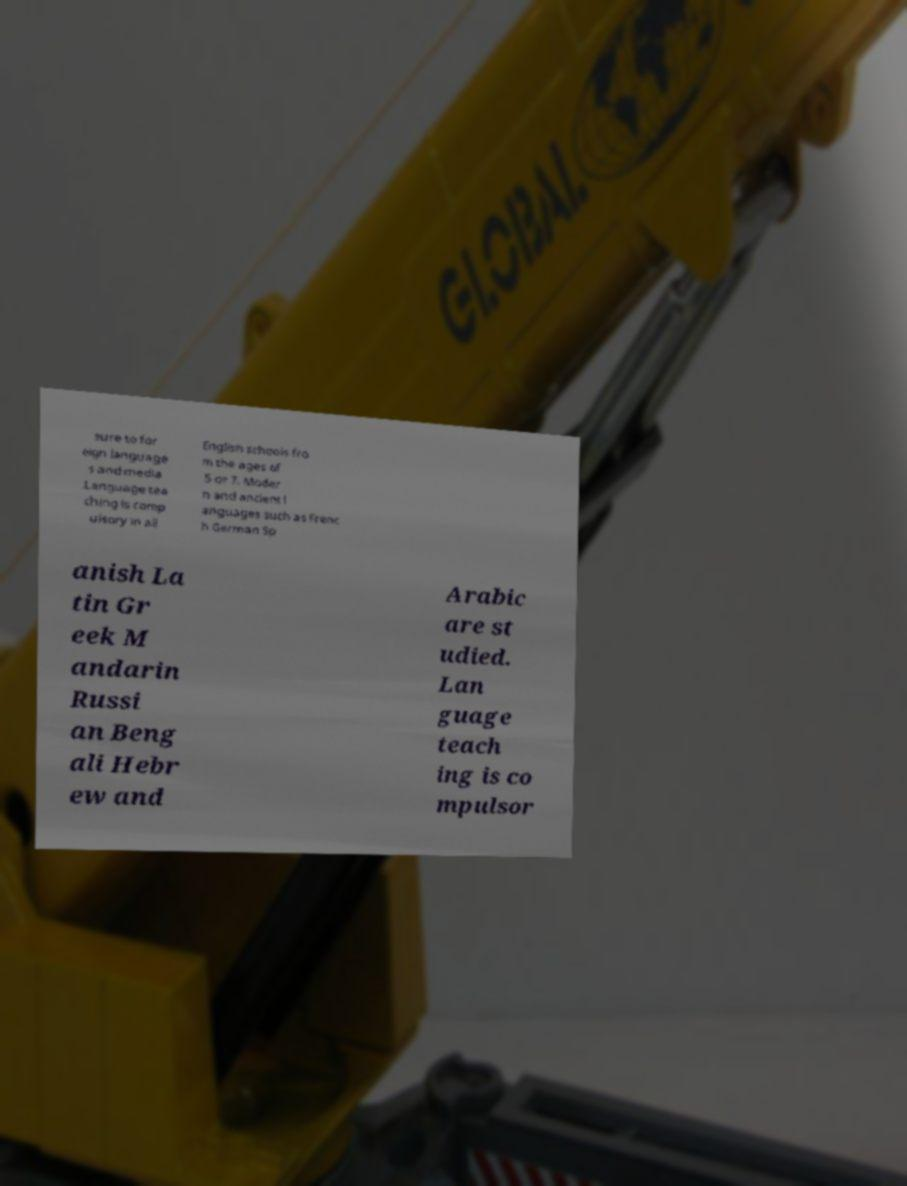Could you assist in decoding the text presented in this image and type it out clearly? sure to for eign language s and media .Language tea ching is comp ulsory in all English schools fro m the ages of 5 or 7. Moder n and ancient l anguages such as Frenc h German Sp anish La tin Gr eek M andarin Russi an Beng ali Hebr ew and Arabic are st udied. Lan guage teach ing is co mpulsor 